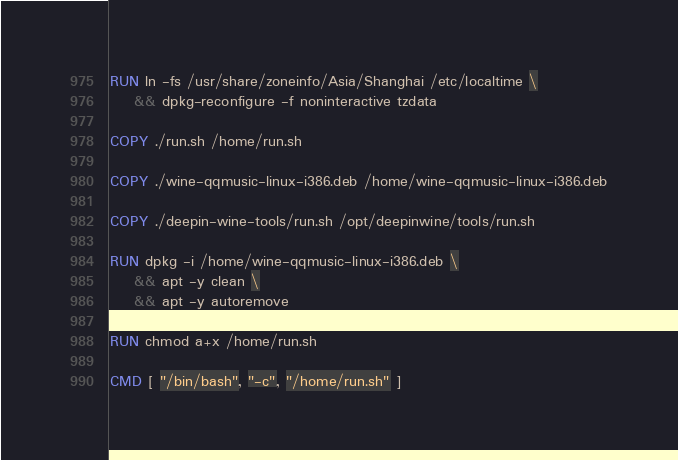<code> <loc_0><loc_0><loc_500><loc_500><_Dockerfile_>
RUN ln -fs /usr/share/zoneinfo/Asia/Shanghai /etc/localtime \
    && dpkg-reconfigure -f noninteractive tzdata

COPY ./run.sh /home/run.sh

COPY ./wine-qqmusic-linux-i386.deb /home/wine-qqmusic-linux-i386.deb

COPY ./deepin-wine-tools/run.sh /opt/deepinwine/tools/run.sh

RUN dpkg -i /home/wine-qqmusic-linux-i386.deb \
    && apt -y clean \
    && apt -y autoremove

RUN chmod a+x /home/run.sh

CMD [ "/bin/bash", "-c", "/home/run.sh" ]</code> 